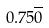<formula> <loc_0><loc_0><loc_500><loc_500>0 . 7 5 \overline { 0 }</formula> 